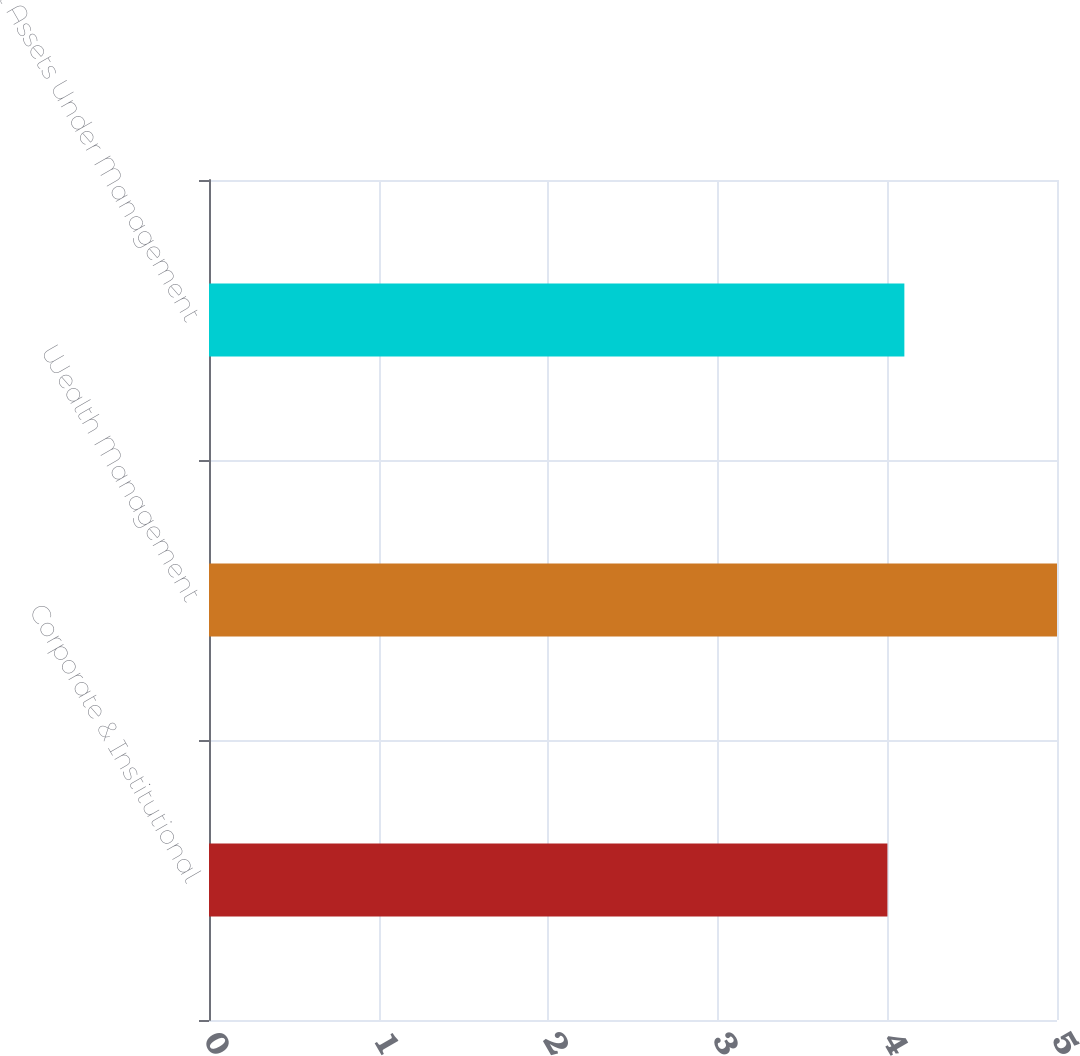Convert chart. <chart><loc_0><loc_0><loc_500><loc_500><bar_chart><fcel>Corporate & Institutional<fcel>Wealth Management<fcel>Total Assets Under Management<nl><fcel>4<fcel>5<fcel>4.1<nl></chart> 